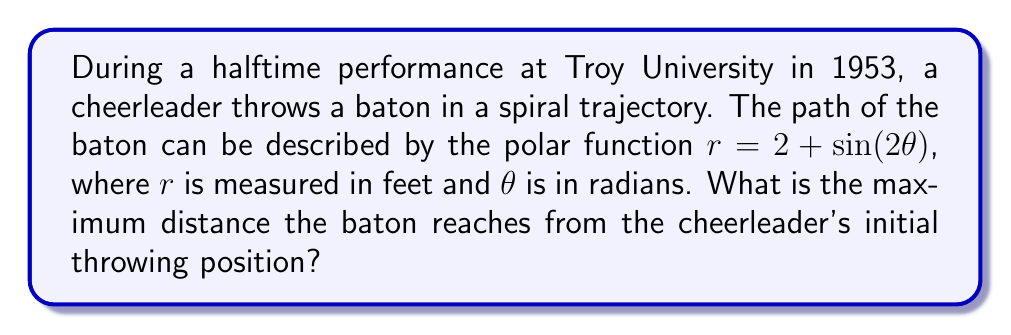Provide a solution to this math problem. To find the maximum distance the baton reaches from the cheerleader's initial position, we need to determine the maximum value of $r$ in the given polar function.

1) The polar function is given as:
   $r = 2 + \sin(2\theta)$

2) The maximum value of $r$ will occur when $\sin(2\theta)$ is at its maximum, which is 1.

3) Therefore, the maximum value of $r$ is:
   $r_{max} = 2 + 1 = 3$

4) This means that at its farthest point, the baton will be 3 feet away from the cheerleader's initial throwing position.

5) We can visualize this using a polar plot:

[asy]
import graph;
size(200);
real r(real t) {return 2+sin(2*t);}
draw(polargraph(r,0,2*pi),blue);
dot((3,0),red);
label("3 ft",(1.5,0),E);
[/asy]

The red dot indicates the maximum distance reached by the baton.
Answer: The maximum distance the baton reaches from the cheerleader's initial throwing position is 3 feet. 